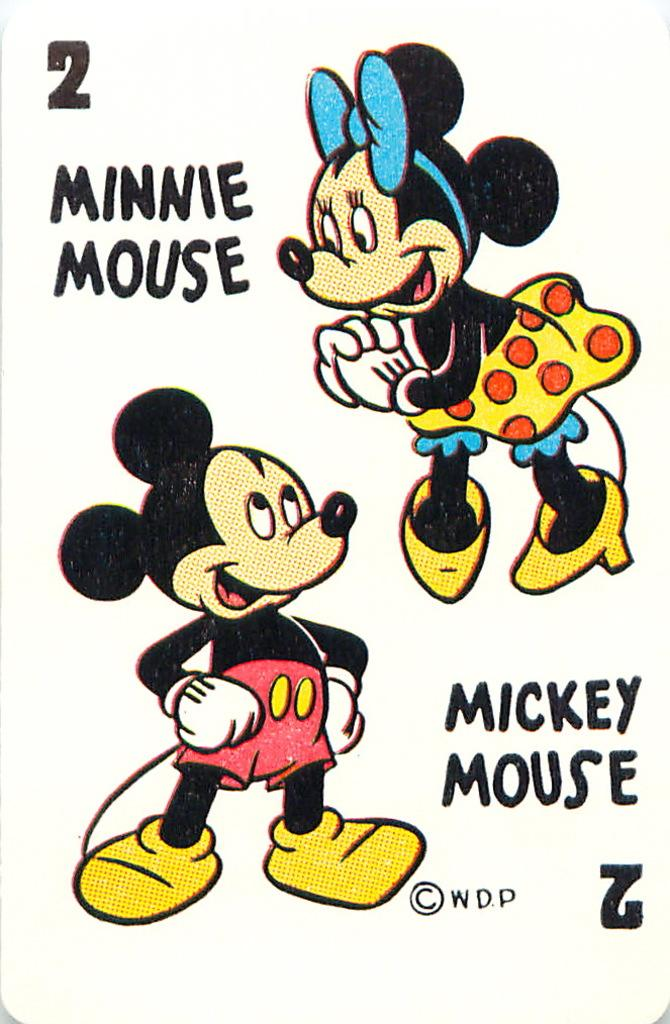What is featured on the poster in the image? The poster contains two Mickey Mouse pictures. What else can be seen on the poster besides the Mickey Mouse pictures? There is text on the poster. What type of branch is depicted in the caption of the poster? There is no branch or caption present in the image; the poster contains two Mickey Mouse pictures and text. How many hands are visible in the image? There are no hands visible in the image; it features a poster with Mickey Mouse pictures and text. 